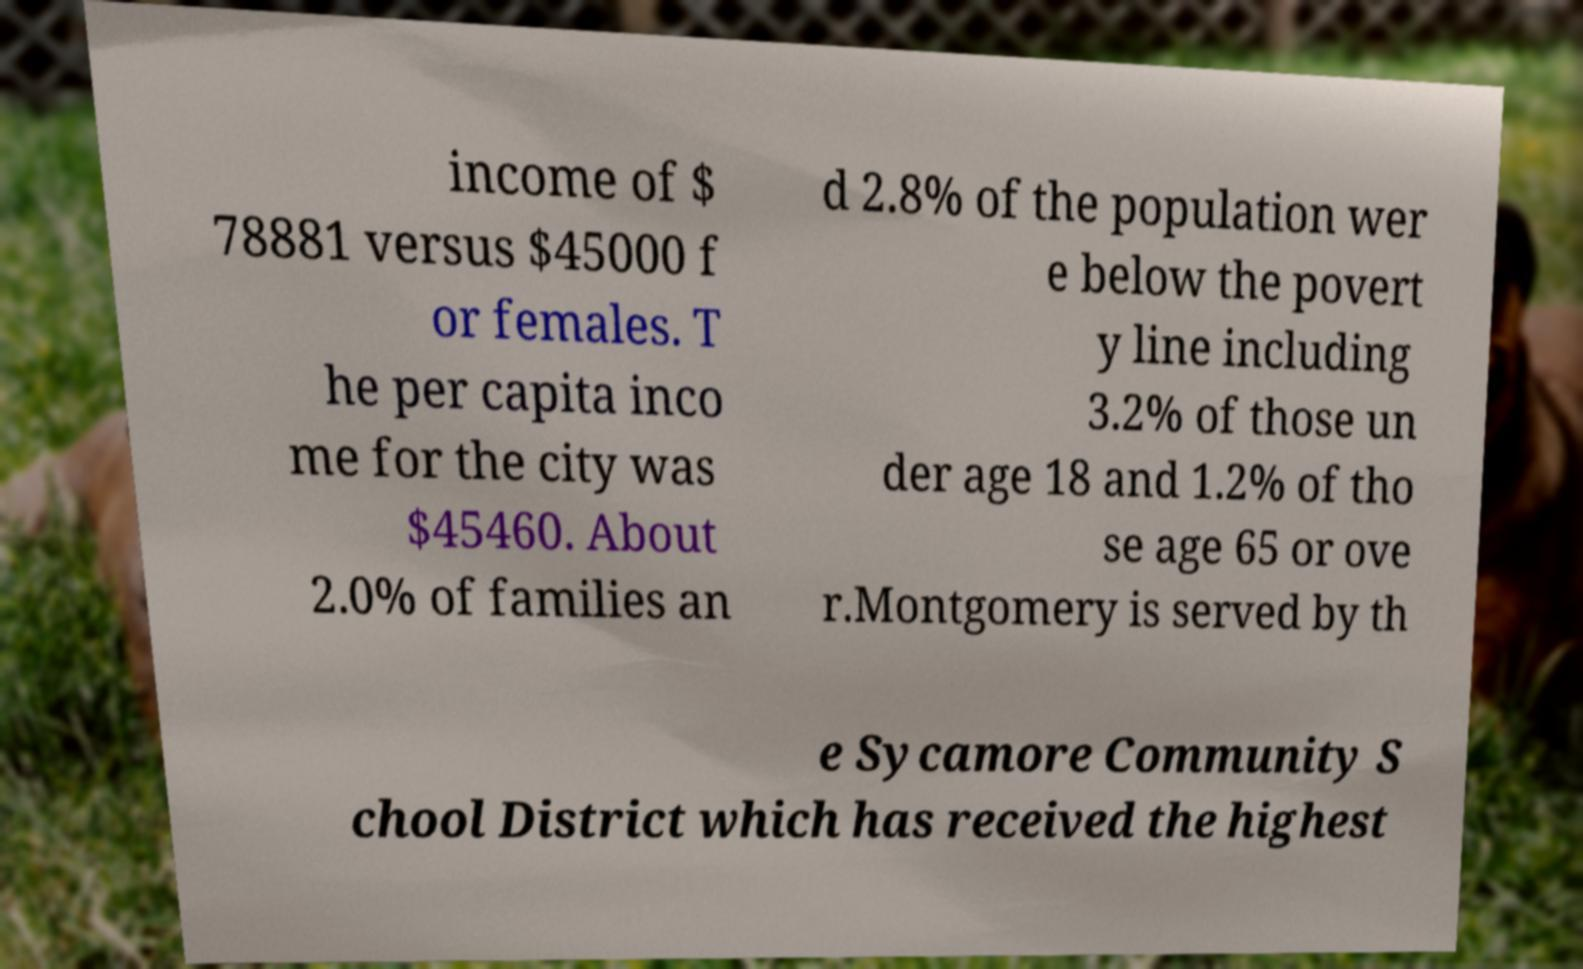What messages or text are displayed in this image? I need them in a readable, typed format. income of $ 78881 versus $45000 f or females. T he per capita inco me for the city was $45460. About 2.0% of families an d 2.8% of the population wer e below the povert y line including 3.2% of those un der age 18 and 1.2% of tho se age 65 or ove r.Montgomery is served by th e Sycamore Community S chool District which has received the highest 